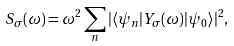<formula> <loc_0><loc_0><loc_500><loc_500>S _ { \sigma } ( \omega ) = \omega ^ { 2 } \sum _ { n } | \langle \psi _ { n } | Y _ { \sigma } ( \omega ) | \psi _ { 0 } \rangle | ^ { 2 } ,</formula> 